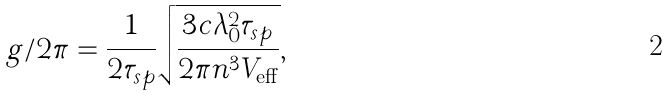Convert formula to latex. <formula><loc_0><loc_0><loc_500><loc_500>g / 2 \pi = \frac { 1 } { 2 \tau _ { s p } } \sqrt { \frac { 3 c \lambda _ { 0 } ^ { 2 } \tau _ { s p } } { 2 \pi { n ^ { 3 } } V _ { \text {eff} } } } , \\</formula> 